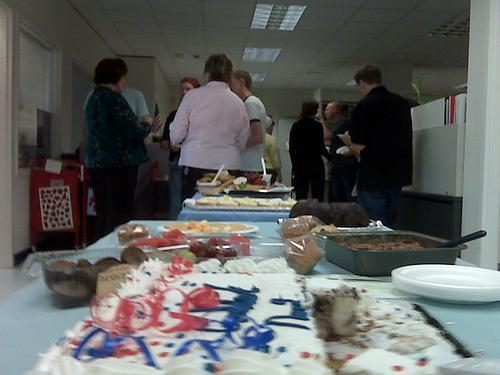How many cakes are there?
Give a very brief answer. 1. How many people are there?
Give a very brief answer. 6. 